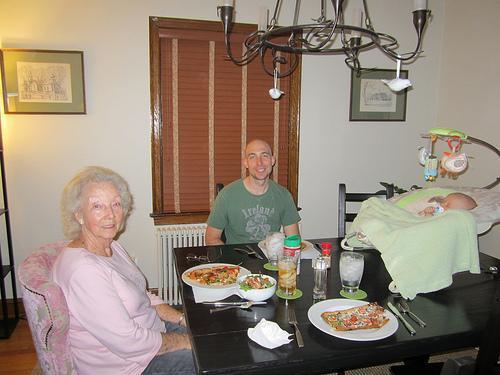How many people are in the picture?
Give a very brief answer. 3. How many windows are in the picture?
Give a very brief answer. 1. 